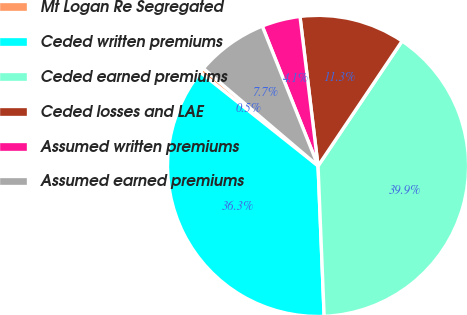Convert chart. <chart><loc_0><loc_0><loc_500><loc_500><pie_chart><fcel>Mt Logan Re Segregated<fcel>Ceded written premiums<fcel>Ceded earned premiums<fcel>Ceded losses and LAE<fcel>Assumed written premiums<fcel>Assumed earned premiums<nl><fcel>0.53%<fcel>36.33%<fcel>39.93%<fcel>11.34%<fcel>4.13%<fcel>7.74%<nl></chart> 